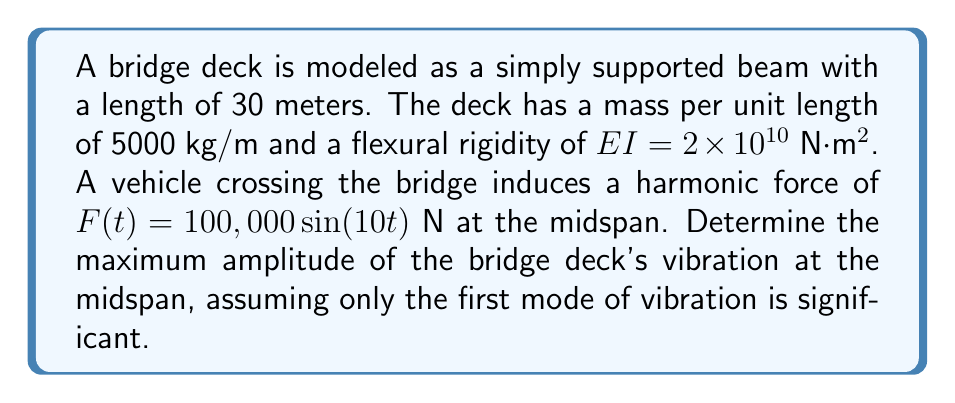Give your solution to this math problem. To solve this problem, we need to follow these steps:

1. Calculate the natural frequency of the first mode:
The natural frequency for a simply supported beam is given by:

$$ \omega_n = \frac{n^2\pi^2}{L^2}\sqrt{\frac{EI}{m}} $$

Where $n$ is the mode number (1 for the first mode), $L$ is the length, $EI$ is the flexural rigidity, and $m$ is the mass per unit length.

$$ \omega_1 = \frac{\pi^2}{30^2}\sqrt{\frac{2 \times 10^{10}}{5000}} = 15.47 \text{ rad/s} $$

2. Determine the forcing frequency:
From the given harmonic force $F(t) = 100,000 \sin(10t)$, we can see that the forcing frequency is $\omega = 10 \text{ rad/s}$.

3. Calculate the dynamic amplification factor:
The dynamic amplification factor is given by:

$$ D = \frac{1}{\sqrt{(1-r^2)^2 + (2\zeta r)^2}} $$

Where $r = \frac{\omega}{\omega_1}$ is the frequency ratio, and $\zeta$ is the damping ratio (assumed to be 0.05 for typical bridge structures).

$$ r = \frac{10}{15.47} = 0.646 $$
$$ D = \frac{1}{\sqrt{(1-0.646^2)^2 + (2 \times 0.05 \times 0.646)^2}} = 1.43 $$

4. Calculate the static deflection:
The static deflection at midspan for a simply supported beam with a point load at midspan is:

$$ \delta_{st} = \frac{FL^3}{48EI} = \frac{100,000 \times 30^3}{48 \times 2 \times 10^{10}} = 0.0281 \text{ m} $$

5. Calculate the maximum dynamic amplitude:
The maximum dynamic amplitude is the product of the static deflection and the dynamic amplification factor:

$$ A_{max} = \delta_{st} \times D = 0.0281 \times 1.43 = 0.0402 \text{ m} $$

Therefore, the maximum amplitude of the bridge deck's vibration at the midspan is 0.0402 meters or 4.02 centimeters.
Answer: The maximum amplitude of the bridge deck's vibration at the midspan is 0.0402 m or 4.02 cm. 